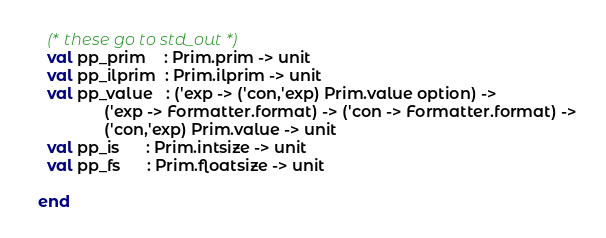Convert code to text. <code><loc_0><loc_0><loc_500><loc_500><_SML_>
    (* these go to std_out *)
    val pp_prim    : Prim.prim -> unit
    val pp_ilprim  : Prim.ilprim -> unit
    val pp_value   : ('exp -> ('con,'exp) Prim.value option) ->
	             ('exp -> Formatter.format) -> ('con -> Formatter.format) ->
	             ('con,'exp) Prim.value -> unit
    val pp_is      : Prim.intsize -> unit
    val pp_fs      : Prim.floatsize -> unit

  end
</code> 